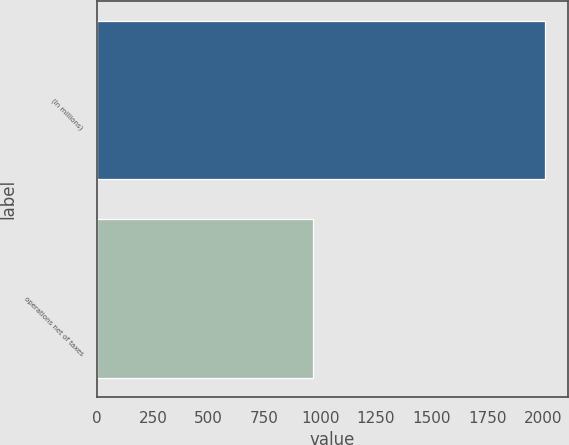<chart> <loc_0><loc_0><loc_500><loc_500><bar_chart><fcel>(In millions)<fcel>operations net of taxes<nl><fcel>2010<fcel>969<nl></chart> 